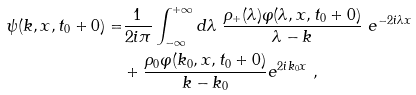Convert formula to latex. <formula><loc_0><loc_0><loc_500><loc_500>\psi ( { k } , x , t _ { 0 } + 0 ) = & { \frac { 1 } { 2 i \pi } } \int _ { - \infty } ^ { + \infty } d \lambda \ \frac { \rho _ { + } ( \lambda ) \varphi ( \lambda , x , t _ { 0 } + 0 ) } { \lambda - { k } } \ e ^ { - 2 i \lambda x } \\ & + \frac { \rho _ { 0 } \varphi ( k _ { 0 } , x , t _ { 0 } + 0 ) } { { k } - k _ { 0 } } e ^ { 2 i k _ { 0 } x } \ ,</formula> 